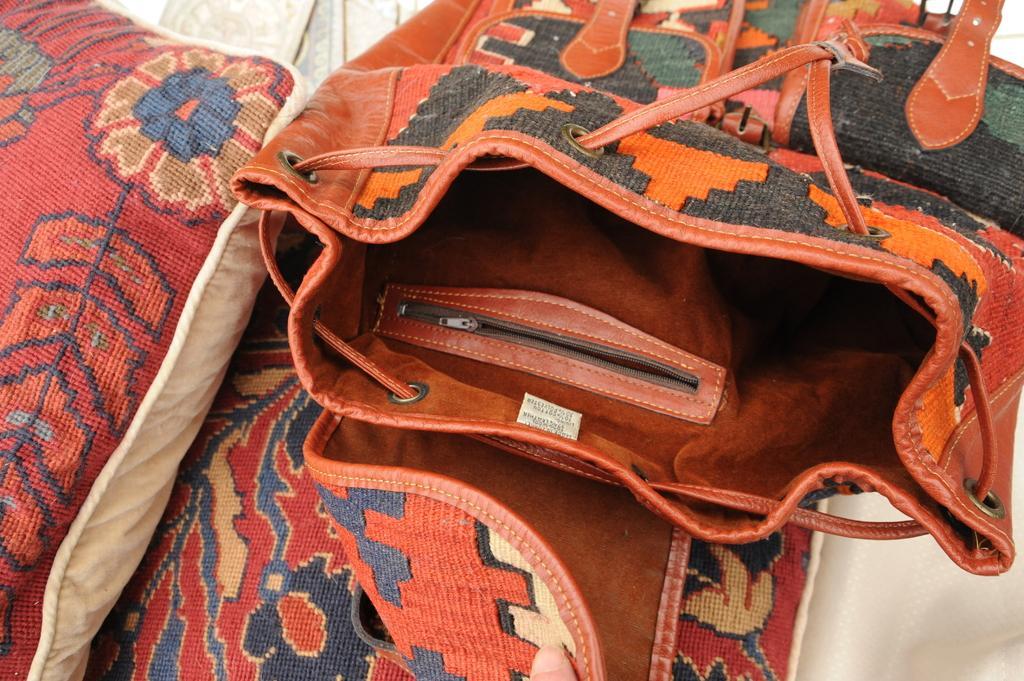Can you describe this image briefly? In this picture we can see a bag. 